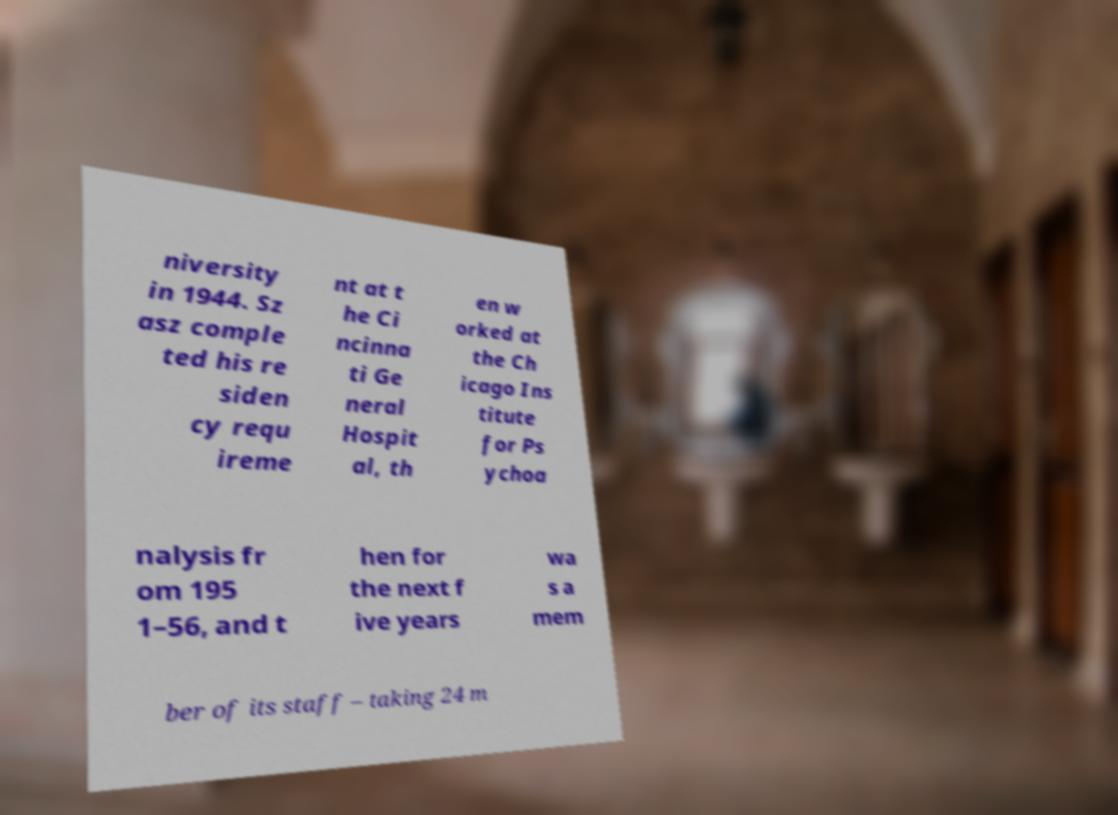Please read and relay the text visible in this image. What does it say? niversity in 1944. Sz asz comple ted his re siden cy requ ireme nt at t he Ci ncinna ti Ge neral Hospit al, th en w orked at the Ch icago Ins titute for Ps ychoa nalysis fr om 195 1–56, and t hen for the next f ive years wa s a mem ber of its staff – taking 24 m 